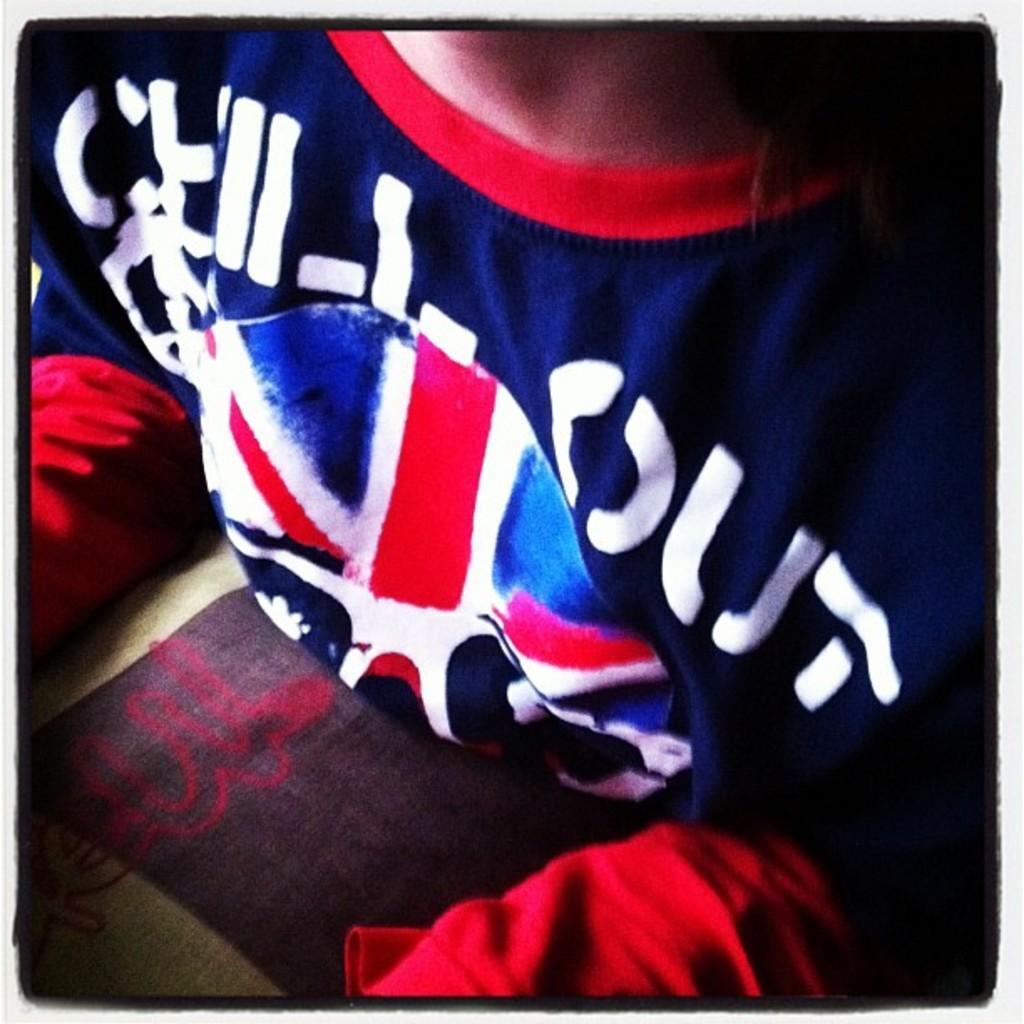<image>
Summarize the visual content of the image. a shirt that has the word chill on it 